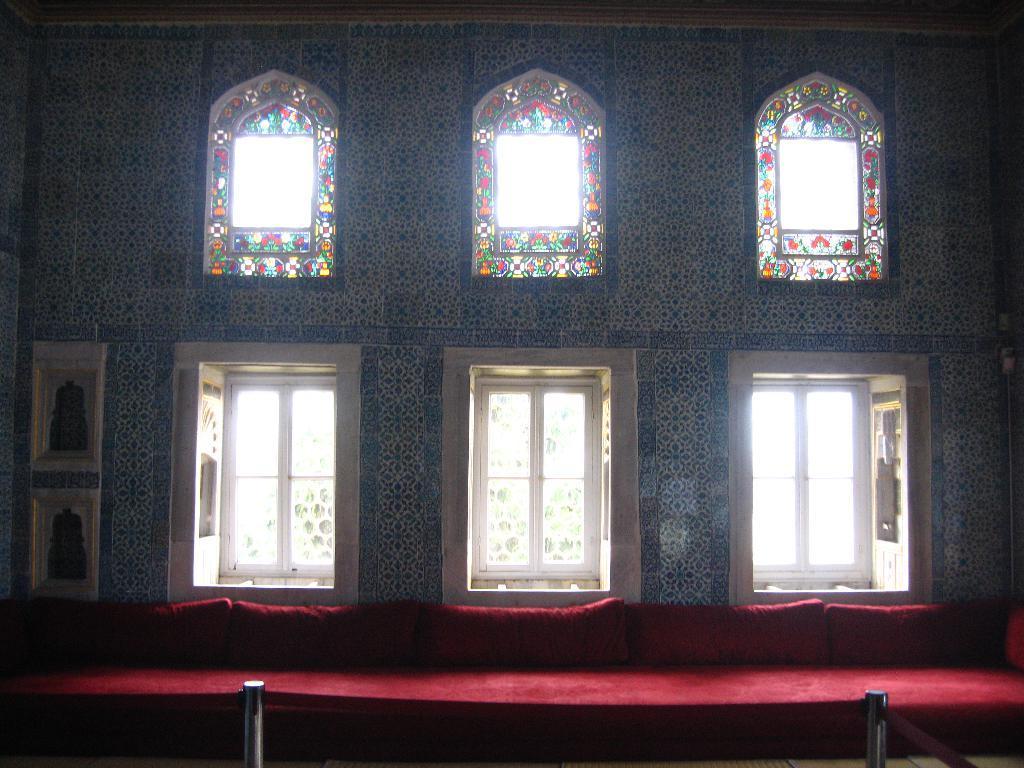Describe this image in one or two sentences. In this image, we can see a carpet on the stage and in the background, there are windows to a wall. 